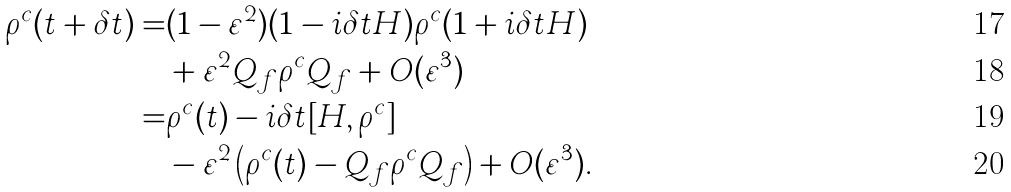<formula> <loc_0><loc_0><loc_500><loc_500>\rho ^ { c } ( t + \delta t ) = & ( 1 - \varepsilon ^ { 2 } ) ( 1 - i \delta t H ) \rho ^ { c } ( 1 + i \delta t H ) \\ & + \varepsilon ^ { 2 } Q _ { f } \rho ^ { c } Q _ { f } + O ( \varepsilon ^ { 3 } ) \\ = & \rho ^ { c } ( t ) - i \delta t [ H , \rho ^ { c } ] \\ & - \varepsilon ^ { 2 } \left ( \rho ^ { c } ( t ) - Q _ { f } \rho ^ { c } Q _ { f } \right ) + O ( \varepsilon ^ { 3 } ) .</formula> 